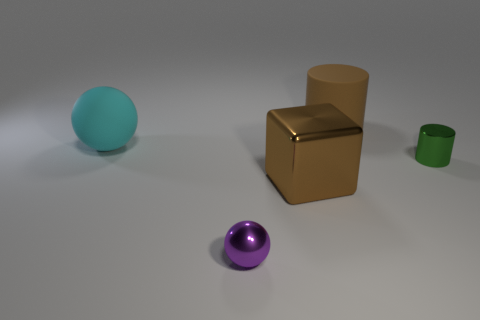Add 4 yellow cubes. How many objects exist? 9 Subtract 1 blocks. How many blocks are left? 0 Subtract all cyan spheres. How many spheres are left? 1 Subtract all blocks. How many objects are left? 4 Add 2 big brown cylinders. How many big brown cylinders are left? 3 Add 1 purple rubber spheres. How many purple rubber spheres exist? 1 Subtract 1 brown cubes. How many objects are left? 4 Subtract all yellow cylinders. Subtract all yellow blocks. How many cylinders are left? 2 Subtract all gray cylinders. How many blue spheres are left? 0 Subtract all large cyan metal blocks. Subtract all spheres. How many objects are left? 3 